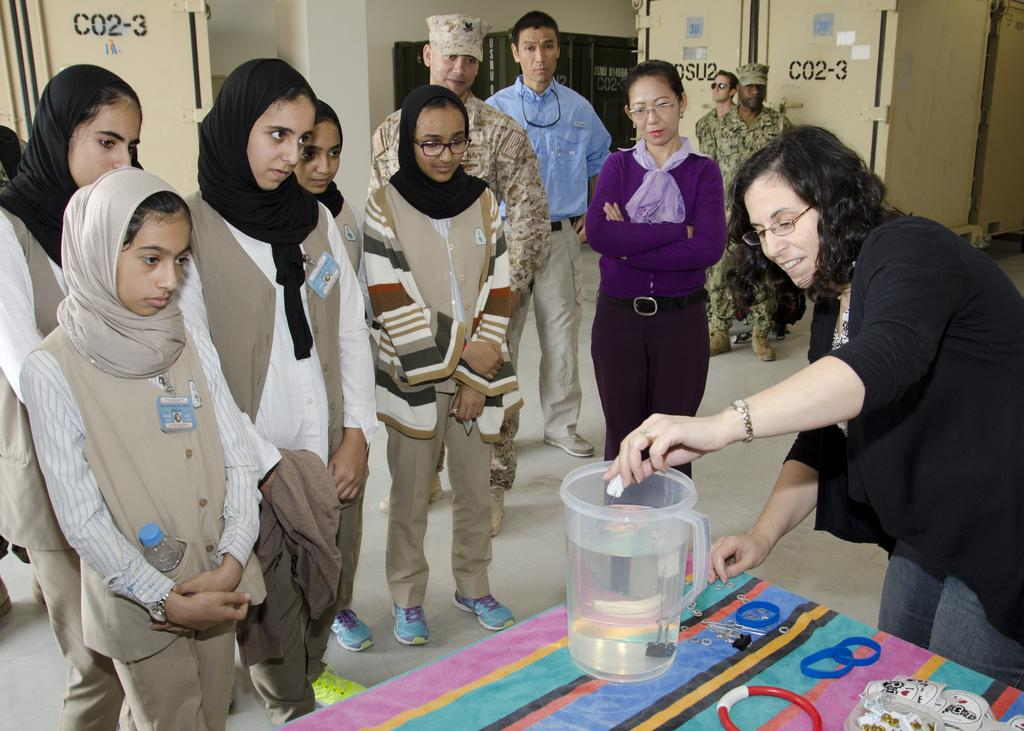<image>
Create a compact narrative representing the image presented. A group of people watch a science experiment at a military base with C02-3 Printed on multiple walls. 